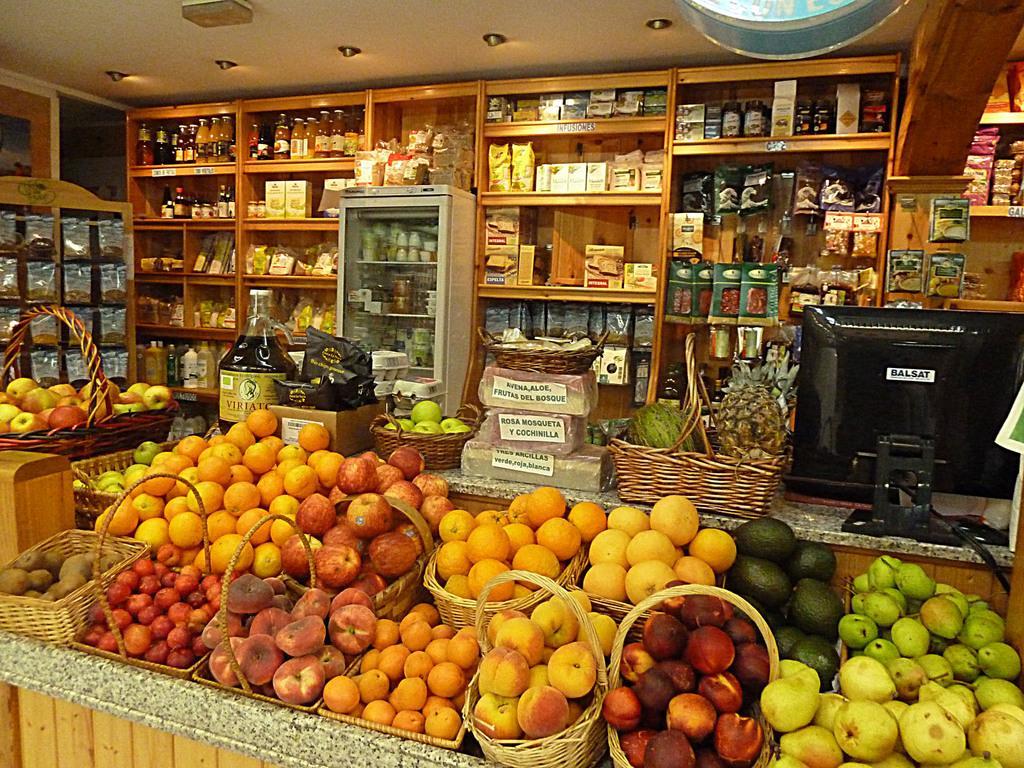Please provide a concise description of this image. This image is taken at the stall. In this image we can see the baskets of fruits. We can also see the monitor. Some text papers attached to the boxes. We can also see the bottles, boxes and some packs arranged on the wooden racks. We can also see a refrigerator. At the top there is ceiling with the ceiling lights. 